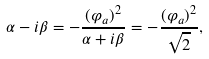Convert formula to latex. <formula><loc_0><loc_0><loc_500><loc_500>\alpha - i \beta = - { \frac { ( \varphi _ { a } ) ^ { 2 } } { \alpha + i \beta } } = - { \frac { ( \varphi _ { a } ) ^ { 2 } } { \sqrt { 2 } } } ,</formula> 